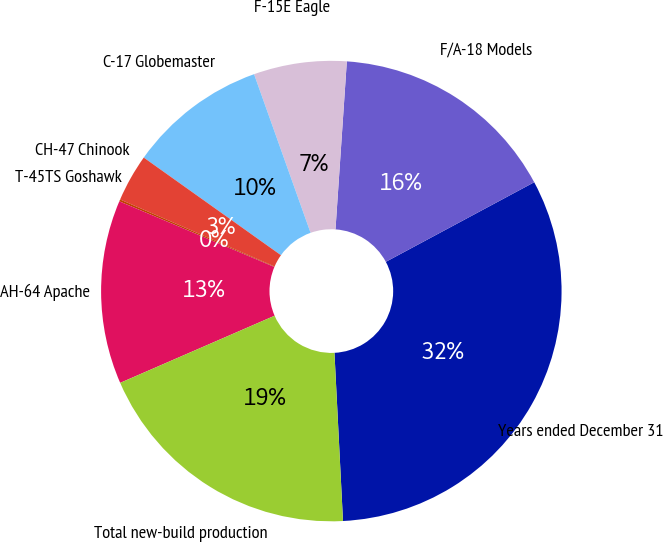Convert chart to OTSL. <chart><loc_0><loc_0><loc_500><loc_500><pie_chart><fcel>Years ended December 31<fcel>F/A-18 Models<fcel>F-15E Eagle<fcel>C-17 Globemaster<fcel>CH-47 Chinook<fcel>T-45TS Goshawk<fcel>AH-64 Apache<fcel>Total new-build production<nl><fcel>32.03%<fcel>16.09%<fcel>6.52%<fcel>9.71%<fcel>3.33%<fcel>0.14%<fcel>12.9%<fcel>19.28%<nl></chart> 